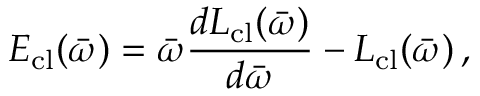<formula> <loc_0><loc_0><loc_500><loc_500>E _ { c l } ( \bar { \omega } ) = \bar { \omega } \frac { d L _ { c l } ( \bar { \omega } ) } { d \bar { \omega } } - L _ { c l } ( \bar { \omega } ) \, ,</formula> 